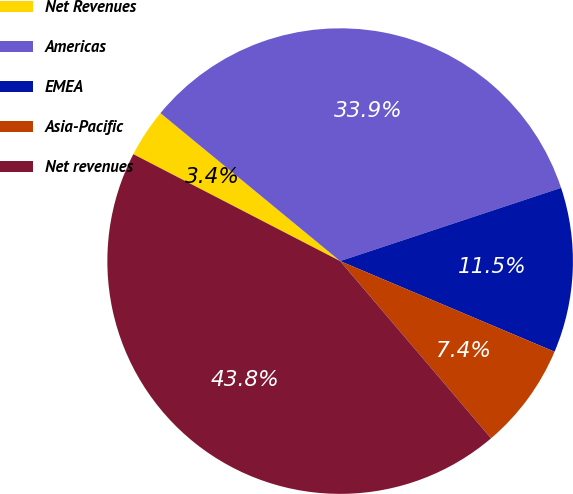Convert chart to OTSL. <chart><loc_0><loc_0><loc_500><loc_500><pie_chart><fcel>Net Revenues<fcel>Americas<fcel>EMEA<fcel>Asia-Pacific<fcel>Net revenues<nl><fcel>3.37%<fcel>33.94%<fcel>11.46%<fcel>7.41%<fcel>43.82%<nl></chart> 